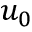Convert formula to latex. <formula><loc_0><loc_0><loc_500><loc_500>u _ { 0 }</formula> 